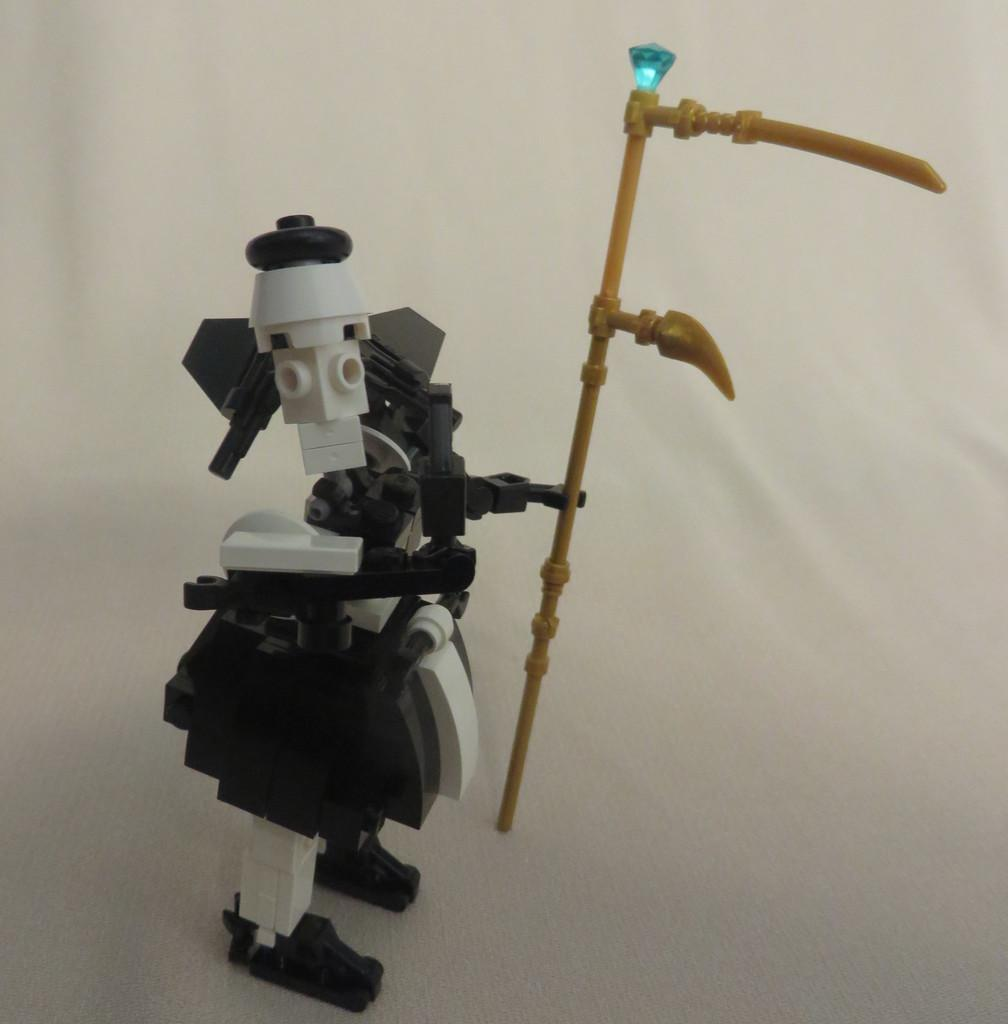What type of toy can be seen in the image? There is a toy made with blocks in the image. What is the toy holding? The toy is holding a stick. What is on the stick that the toy is holding? There is a stone on the stick. What color is the background of the image? The background of the image is white. What type of quartz can be seen in the image? There is no quartz present in the image. What kind of jewel is the toy wearing in the image? There is no jewel present in the image; the toy is holding a stick with a stone on it. 